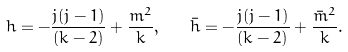Convert formula to latex. <formula><loc_0><loc_0><loc_500><loc_500>h = - \frac { j ( j - 1 ) } { ( k - 2 ) } + \frac { m ^ { 2 } } { k } , \quad \bar { h } = - \frac { j ( j - 1 ) } { ( k - 2 ) } + \frac { \bar { m } ^ { 2 } } { k } .</formula> 